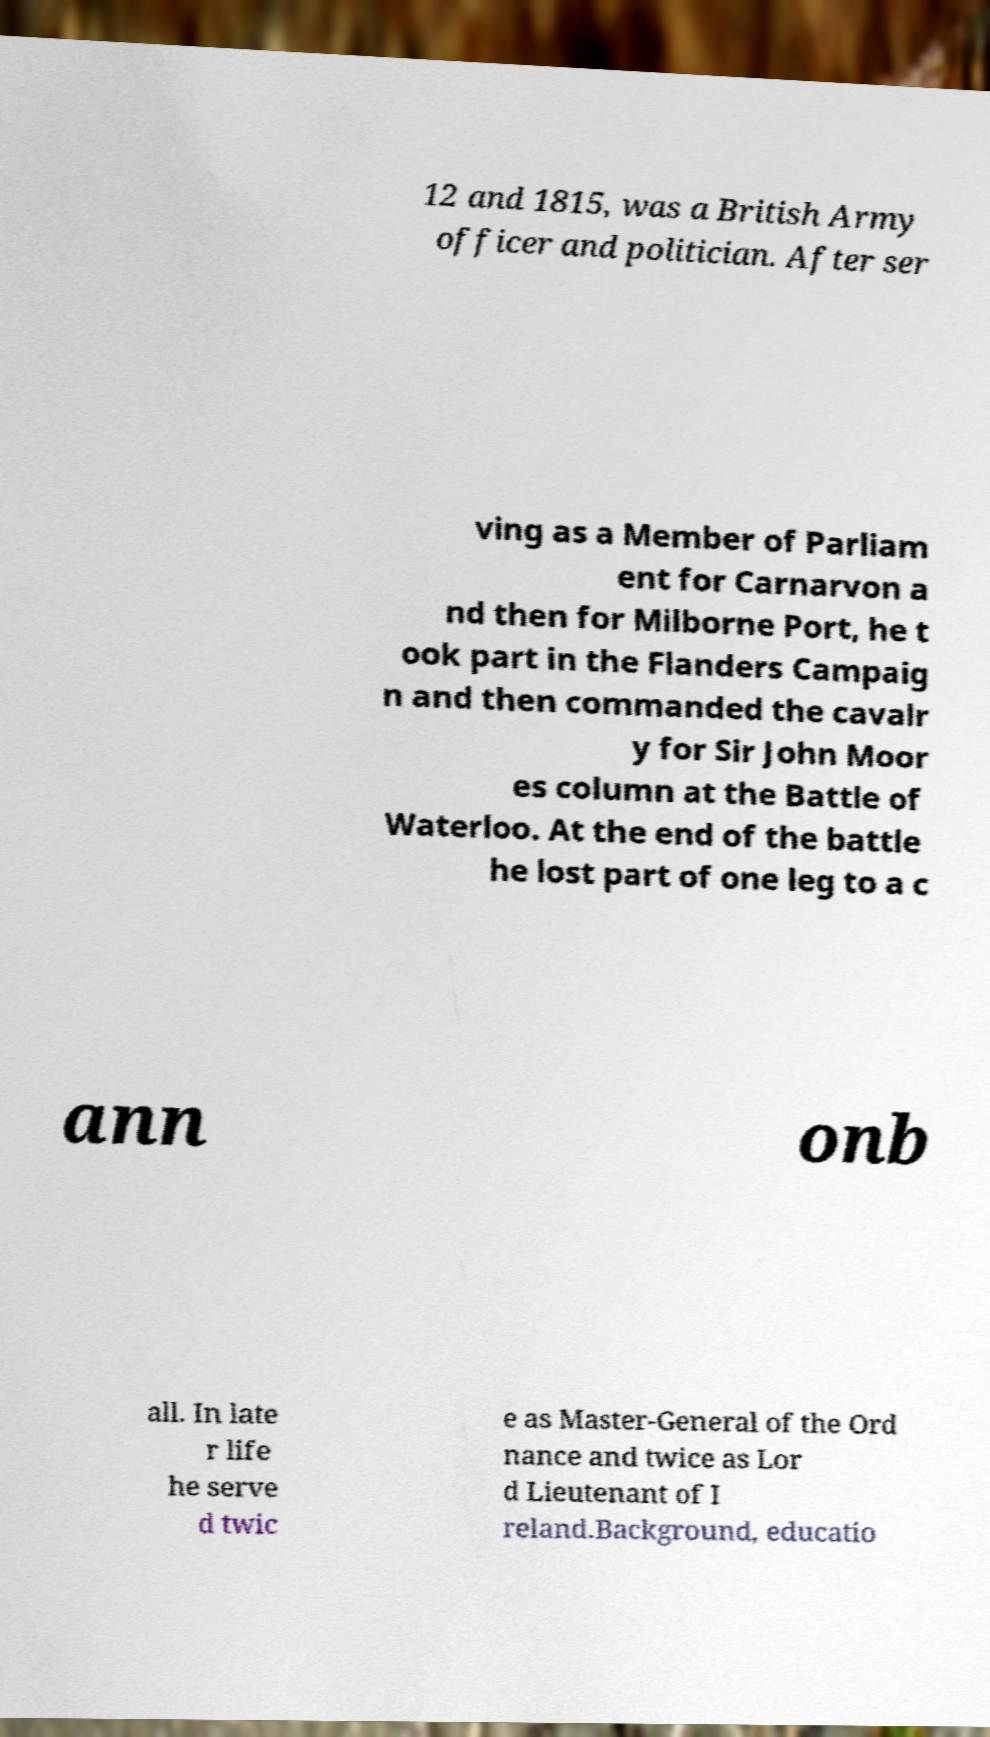Please read and relay the text visible in this image. What does it say? 12 and 1815, was a British Army officer and politician. After ser ving as a Member of Parliam ent for Carnarvon a nd then for Milborne Port, he t ook part in the Flanders Campaig n and then commanded the cavalr y for Sir John Moor es column at the Battle of Waterloo. At the end of the battle he lost part of one leg to a c ann onb all. In late r life he serve d twic e as Master-General of the Ord nance and twice as Lor d Lieutenant of I reland.Background, educatio 